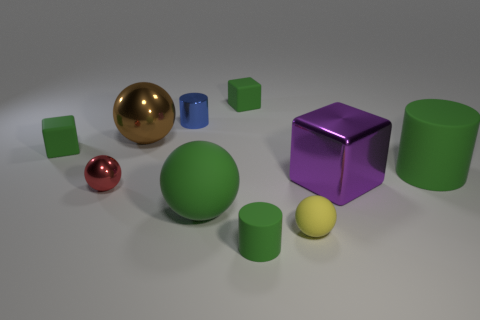Are there fewer large purple metal things that are in front of the red ball than metallic cubes?
Make the answer very short. Yes. How many small objects are blue things or red metallic balls?
Offer a very short reply. 2. The yellow object has what size?
Make the answer very short. Small. Are there any other things that are made of the same material as the small yellow thing?
Ensure brevity in your answer.  Yes. There is a red object; how many shiny objects are behind it?
Offer a very short reply. 3. What is the size of the red metal object that is the same shape as the tiny yellow rubber thing?
Your response must be concise. Small. There is a metal object that is in front of the large shiny ball and on the left side of the blue metal cylinder; what is its size?
Provide a succinct answer. Small. Is the color of the shiny cube the same as the object that is behind the small blue metallic object?
Your answer should be compact. No. What number of gray objects are matte cubes or big balls?
Your answer should be very brief. 0. What is the shape of the tiny yellow matte object?
Provide a short and direct response. Sphere. 